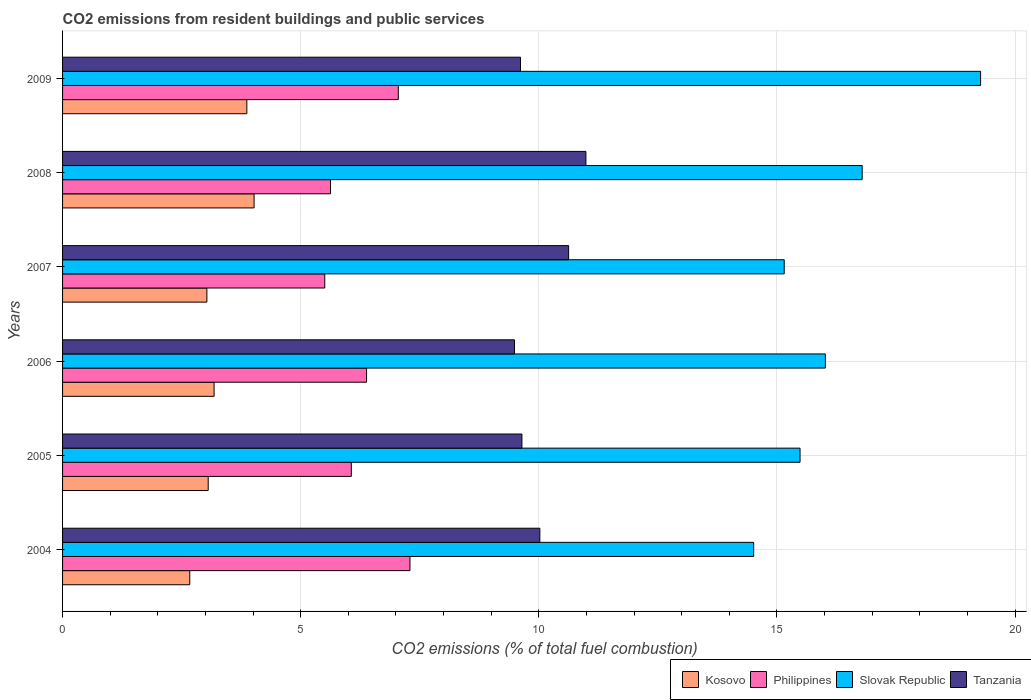Are the number of bars per tick equal to the number of legend labels?
Provide a succinct answer. Yes. Are the number of bars on each tick of the Y-axis equal?
Provide a succinct answer. Yes. How many bars are there on the 2nd tick from the top?
Give a very brief answer. 4. What is the total CO2 emitted in Philippines in 2008?
Provide a short and direct response. 5.63. Across all years, what is the maximum total CO2 emitted in Slovak Republic?
Provide a succinct answer. 19.28. Across all years, what is the minimum total CO2 emitted in Slovak Republic?
Provide a short and direct response. 14.51. In which year was the total CO2 emitted in Tanzania maximum?
Give a very brief answer. 2008. In which year was the total CO2 emitted in Slovak Republic minimum?
Your response must be concise. 2004. What is the total total CO2 emitted in Slovak Republic in the graph?
Your response must be concise. 97.23. What is the difference between the total CO2 emitted in Tanzania in 2004 and that in 2008?
Keep it short and to the point. -0.97. What is the difference between the total CO2 emitted in Tanzania in 2006 and the total CO2 emitted in Philippines in 2008?
Your answer should be very brief. 3.86. What is the average total CO2 emitted in Philippines per year?
Provide a succinct answer. 6.32. In the year 2007, what is the difference between the total CO2 emitted in Tanzania and total CO2 emitted in Philippines?
Your answer should be very brief. 5.12. In how many years, is the total CO2 emitted in Philippines greater than 10 ?
Keep it short and to the point. 0. What is the ratio of the total CO2 emitted in Philippines in 2005 to that in 2009?
Your answer should be very brief. 0.86. Is the total CO2 emitted in Philippines in 2007 less than that in 2009?
Provide a succinct answer. Yes. What is the difference between the highest and the second highest total CO2 emitted in Tanzania?
Make the answer very short. 0.36. What is the difference between the highest and the lowest total CO2 emitted in Kosovo?
Your answer should be very brief. 1.35. Is the sum of the total CO2 emitted in Slovak Republic in 2004 and 2006 greater than the maximum total CO2 emitted in Philippines across all years?
Ensure brevity in your answer.  Yes. What does the 4th bar from the top in 2009 represents?
Offer a very short reply. Kosovo. What does the 3rd bar from the bottom in 2004 represents?
Ensure brevity in your answer.  Slovak Republic. Are all the bars in the graph horizontal?
Give a very brief answer. Yes. Are the values on the major ticks of X-axis written in scientific E-notation?
Provide a short and direct response. No. Does the graph contain grids?
Provide a succinct answer. Yes. What is the title of the graph?
Provide a short and direct response. CO2 emissions from resident buildings and public services. What is the label or title of the X-axis?
Keep it short and to the point. CO2 emissions (% of total fuel combustion). What is the CO2 emissions (% of total fuel combustion) in Kosovo in 2004?
Make the answer very short. 2.67. What is the CO2 emissions (% of total fuel combustion) of Philippines in 2004?
Provide a succinct answer. 7.29. What is the CO2 emissions (% of total fuel combustion) in Slovak Republic in 2004?
Your answer should be very brief. 14.51. What is the CO2 emissions (% of total fuel combustion) in Tanzania in 2004?
Offer a terse response. 10.02. What is the CO2 emissions (% of total fuel combustion) of Kosovo in 2005?
Keep it short and to the point. 3.06. What is the CO2 emissions (% of total fuel combustion) in Philippines in 2005?
Your response must be concise. 6.06. What is the CO2 emissions (% of total fuel combustion) of Slovak Republic in 2005?
Your response must be concise. 15.49. What is the CO2 emissions (% of total fuel combustion) of Tanzania in 2005?
Provide a short and direct response. 9.65. What is the CO2 emissions (% of total fuel combustion) in Kosovo in 2006?
Your answer should be compact. 3.18. What is the CO2 emissions (% of total fuel combustion) in Philippines in 2006?
Make the answer very short. 6.38. What is the CO2 emissions (% of total fuel combustion) of Slovak Republic in 2006?
Make the answer very short. 16.02. What is the CO2 emissions (% of total fuel combustion) in Tanzania in 2006?
Give a very brief answer. 9.49. What is the CO2 emissions (% of total fuel combustion) in Kosovo in 2007?
Your answer should be very brief. 3.03. What is the CO2 emissions (% of total fuel combustion) of Philippines in 2007?
Offer a very short reply. 5.51. What is the CO2 emissions (% of total fuel combustion) in Slovak Republic in 2007?
Make the answer very short. 15.15. What is the CO2 emissions (% of total fuel combustion) in Tanzania in 2007?
Your answer should be very brief. 10.63. What is the CO2 emissions (% of total fuel combustion) of Kosovo in 2008?
Offer a very short reply. 4.02. What is the CO2 emissions (% of total fuel combustion) in Philippines in 2008?
Give a very brief answer. 5.63. What is the CO2 emissions (% of total fuel combustion) of Slovak Republic in 2008?
Your answer should be very brief. 16.79. What is the CO2 emissions (% of total fuel combustion) of Tanzania in 2008?
Your answer should be very brief. 10.99. What is the CO2 emissions (% of total fuel combustion) in Kosovo in 2009?
Offer a terse response. 3.87. What is the CO2 emissions (% of total fuel combustion) in Philippines in 2009?
Offer a terse response. 7.05. What is the CO2 emissions (% of total fuel combustion) in Slovak Republic in 2009?
Your response must be concise. 19.28. What is the CO2 emissions (% of total fuel combustion) in Tanzania in 2009?
Your answer should be compact. 9.62. Across all years, what is the maximum CO2 emissions (% of total fuel combustion) in Kosovo?
Your answer should be compact. 4.02. Across all years, what is the maximum CO2 emissions (% of total fuel combustion) in Philippines?
Your answer should be very brief. 7.29. Across all years, what is the maximum CO2 emissions (% of total fuel combustion) of Slovak Republic?
Your answer should be very brief. 19.28. Across all years, what is the maximum CO2 emissions (% of total fuel combustion) in Tanzania?
Your answer should be very brief. 10.99. Across all years, what is the minimum CO2 emissions (% of total fuel combustion) of Kosovo?
Your answer should be compact. 2.67. Across all years, what is the minimum CO2 emissions (% of total fuel combustion) in Philippines?
Provide a succinct answer. 5.51. Across all years, what is the minimum CO2 emissions (% of total fuel combustion) of Slovak Republic?
Offer a very short reply. 14.51. Across all years, what is the minimum CO2 emissions (% of total fuel combustion) in Tanzania?
Ensure brevity in your answer.  9.49. What is the total CO2 emissions (% of total fuel combustion) in Kosovo in the graph?
Make the answer very short. 19.83. What is the total CO2 emissions (% of total fuel combustion) in Philippines in the graph?
Your answer should be very brief. 37.92. What is the total CO2 emissions (% of total fuel combustion) in Slovak Republic in the graph?
Provide a succinct answer. 97.23. What is the total CO2 emissions (% of total fuel combustion) of Tanzania in the graph?
Give a very brief answer. 60.39. What is the difference between the CO2 emissions (% of total fuel combustion) in Kosovo in 2004 and that in 2005?
Give a very brief answer. -0.39. What is the difference between the CO2 emissions (% of total fuel combustion) of Philippines in 2004 and that in 2005?
Your answer should be very brief. 1.23. What is the difference between the CO2 emissions (% of total fuel combustion) of Slovak Republic in 2004 and that in 2005?
Offer a very short reply. -0.97. What is the difference between the CO2 emissions (% of total fuel combustion) in Tanzania in 2004 and that in 2005?
Provide a succinct answer. 0.38. What is the difference between the CO2 emissions (% of total fuel combustion) in Kosovo in 2004 and that in 2006?
Give a very brief answer. -0.51. What is the difference between the CO2 emissions (% of total fuel combustion) in Philippines in 2004 and that in 2006?
Ensure brevity in your answer.  0.91. What is the difference between the CO2 emissions (% of total fuel combustion) of Slovak Republic in 2004 and that in 2006?
Ensure brevity in your answer.  -1.51. What is the difference between the CO2 emissions (% of total fuel combustion) in Tanzania in 2004 and that in 2006?
Provide a short and direct response. 0.53. What is the difference between the CO2 emissions (% of total fuel combustion) of Kosovo in 2004 and that in 2007?
Your response must be concise. -0.36. What is the difference between the CO2 emissions (% of total fuel combustion) in Philippines in 2004 and that in 2007?
Offer a very short reply. 1.79. What is the difference between the CO2 emissions (% of total fuel combustion) of Slovak Republic in 2004 and that in 2007?
Keep it short and to the point. -0.64. What is the difference between the CO2 emissions (% of total fuel combustion) in Tanzania in 2004 and that in 2007?
Offer a terse response. -0.6. What is the difference between the CO2 emissions (% of total fuel combustion) in Kosovo in 2004 and that in 2008?
Keep it short and to the point. -1.35. What is the difference between the CO2 emissions (% of total fuel combustion) of Philippines in 2004 and that in 2008?
Provide a succinct answer. 1.67. What is the difference between the CO2 emissions (% of total fuel combustion) in Slovak Republic in 2004 and that in 2008?
Provide a succinct answer. -2.28. What is the difference between the CO2 emissions (% of total fuel combustion) of Tanzania in 2004 and that in 2008?
Ensure brevity in your answer.  -0.97. What is the difference between the CO2 emissions (% of total fuel combustion) in Kosovo in 2004 and that in 2009?
Provide a succinct answer. -1.2. What is the difference between the CO2 emissions (% of total fuel combustion) of Philippines in 2004 and that in 2009?
Offer a terse response. 0.24. What is the difference between the CO2 emissions (% of total fuel combustion) in Slovak Republic in 2004 and that in 2009?
Provide a short and direct response. -4.76. What is the difference between the CO2 emissions (% of total fuel combustion) in Tanzania in 2004 and that in 2009?
Ensure brevity in your answer.  0.41. What is the difference between the CO2 emissions (% of total fuel combustion) of Kosovo in 2005 and that in 2006?
Keep it short and to the point. -0.12. What is the difference between the CO2 emissions (% of total fuel combustion) in Philippines in 2005 and that in 2006?
Offer a terse response. -0.32. What is the difference between the CO2 emissions (% of total fuel combustion) of Slovak Republic in 2005 and that in 2006?
Your response must be concise. -0.53. What is the difference between the CO2 emissions (% of total fuel combustion) in Tanzania in 2005 and that in 2006?
Provide a succinct answer. 0.16. What is the difference between the CO2 emissions (% of total fuel combustion) of Kosovo in 2005 and that in 2007?
Your response must be concise. 0.03. What is the difference between the CO2 emissions (% of total fuel combustion) in Philippines in 2005 and that in 2007?
Your response must be concise. 0.56. What is the difference between the CO2 emissions (% of total fuel combustion) of Slovak Republic in 2005 and that in 2007?
Provide a short and direct response. 0.33. What is the difference between the CO2 emissions (% of total fuel combustion) in Tanzania in 2005 and that in 2007?
Provide a succinct answer. -0.98. What is the difference between the CO2 emissions (% of total fuel combustion) in Kosovo in 2005 and that in 2008?
Provide a short and direct response. -0.96. What is the difference between the CO2 emissions (% of total fuel combustion) in Philippines in 2005 and that in 2008?
Offer a very short reply. 0.44. What is the difference between the CO2 emissions (% of total fuel combustion) of Slovak Republic in 2005 and that in 2008?
Provide a short and direct response. -1.3. What is the difference between the CO2 emissions (% of total fuel combustion) in Tanzania in 2005 and that in 2008?
Provide a short and direct response. -1.34. What is the difference between the CO2 emissions (% of total fuel combustion) of Kosovo in 2005 and that in 2009?
Keep it short and to the point. -0.81. What is the difference between the CO2 emissions (% of total fuel combustion) in Philippines in 2005 and that in 2009?
Your response must be concise. -0.99. What is the difference between the CO2 emissions (% of total fuel combustion) in Slovak Republic in 2005 and that in 2009?
Ensure brevity in your answer.  -3.79. What is the difference between the CO2 emissions (% of total fuel combustion) of Tanzania in 2005 and that in 2009?
Ensure brevity in your answer.  0.03. What is the difference between the CO2 emissions (% of total fuel combustion) in Kosovo in 2006 and that in 2007?
Offer a very short reply. 0.15. What is the difference between the CO2 emissions (% of total fuel combustion) of Philippines in 2006 and that in 2007?
Ensure brevity in your answer.  0.88. What is the difference between the CO2 emissions (% of total fuel combustion) of Slovak Republic in 2006 and that in 2007?
Offer a terse response. 0.86. What is the difference between the CO2 emissions (% of total fuel combustion) of Tanzania in 2006 and that in 2007?
Offer a very short reply. -1.14. What is the difference between the CO2 emissions (% of total fuel combustion) in Kosovo in 2006 and that in 2008?
Your response must be concise. -0.84. What is the difference between the CO2 emissions (% of total fuel combustion) in Philippines in 2006 and that in 2008?
Your response must be concise. 0.76. What is the difference between the CO2 emissions (% of total fuel combustion) in Slovak Republic in 2006 and that in 2008?
Provide a short and direct response. -0.77. What is the difference between the CO2 emissions (% of total fuel combustion) of Kosovo in 2006 and that in 2009?
Give a very brief answer. -0.69. What is the difference between the CO2 emissions (% of total fuel combustion) in Philippines in 2006 and that in 2009?
Your response must be concise. -0.67. What is the difference between the CO2 emissions (% of total fuel combustion) of Slovak Republic in 2006 and that in 2009?
Provide a short and direct response. -3.26. What is the difference between the CO2 emissions (% of total fuel combustion) in Tanzania in 2006 and that in 2009?
Provide a short and direct response. -0.13. What is the difference between the CO2 emissions (% of total fuel combustion) of Kosovo in 2007 and that in 2008?
Make the answer very short. -0.99. What is the difference between the CO2 emissions (% of total fuel combustion) of Philippines in 2007 and that in 2008?
Offer a terse response. -0.12. What is the difference between the CO2 emissions (% of total fuel combustion) in Slovak Republic in 2007 and that in 2008?
Keep it short and to the point. -1.64. What is the difference between the CO2 emissions (% of total fuel combustion) of Tanzania in 2007 and that in 2008?
Offer a very short reply. -0.36. What is the difference between the CO2 emissions (% of total fuel combustion) in Kosovo in 2007 and that in 2009?
Provide a succinct answer. -0.84. What is the difference between the CO2 emissions (% of total fuel combustion) of Philippines in 2007 and that in 2009?
Provide a short and direct response. -1.54. What is the difference between the CO2 emissions (% of total fuel combustion) in Slovak Republic in 2007 and that in 2009?
Your response must be concise. -4.12. What is the difference between the CO2 emissions (% of total fuel combustion) in Tanzania in 2007 and that in 2009?
Give a very brief answer. 1.01. What is the difference between the CO2 emissions (% of total fuel combustion) of Kosovo in 2008 and that in 2009?
Provide a short and direct response. 0.15. What is the difference between the CO2 emissions (% of total fuel combustion) in Philippines in 2008 and that in 2009?
Make the answer very short. -1.42. What is the difference between the CO2 emissions (% of total fuel combustion) in Slovak Republic in 2008 and that in 2009?
Your answer should be very brief. -2.49. What is the difference between the CO2 emissions (% of total fuel combustion) of Tanzania in 2008 and that in 2009?
Provide a succinct answer. 1.37. What is the difference between the CO2 emissions (% of total fuel combustion) in Kosovo in 2004 and the CO2 emissions (% of total fuel combustion) in Philippines in 2005?
Ensure brevity in your answer.  -3.39. What is the difference between the CO2 emissions (% of total fuel combustion) of Kosovo in 2004 and the CO2 emissions (% of total fuel combustion) of Slovak Republic in 2005?
Give a very brief answer. -12.81. What is the difference between the CO2 emissions (% of total fuel combustion) of Kosovo in 2004 and the CO2 emissions (% of total fuel combustion) of Tanzania in 2005?
Keep it short and to the point. -6.97. What is the difference between the CO2 emissions (% of total fuel combustion) in Philippines in 2004 and the CO2 emissions (% of total fuel combustion) in Slovak Republic in 2005?
Offer a very short reply. -8.19. What is the difference between the CO2 emissions (% of total fuel combustion) of Philippines in 2004 and the CO2 emissions (% of total fuel combustion) of Tanzania in 2005?
Give a very brief answer. -2.35. What is the difference between the CO2 emissions (% of total fuel combustion) in Slovak Republic in 2004 and the CO2 emissions (% of total fuel combustion) in Tanzania in 2005?
Keep it short and to the point. 4.87. What is the difference between the CO2 emissions (% of total fuel combustion) in Kosovo in 2004 and the CO2 emissions (% of total fuel combustion) in Philippines in 2006?
Keep it short and to the point. -3.71. What is the difference between the CO2 emissions (% of total fuel combustion) in Kosovo in 2004 and the CO2 emissions (% of total fuel combustion) in Slovak Republic in 2006?
Give a very brief answer. -13.35. What is the difference between the CO2 emissions (% of total fuel combustion) in Kosovo in 2004 and the CO2 emissions (% of total fuel combustion) in Tanzania in 2006?
Offer a very short reply. -6.82. What is the difference between the CO2 emissions (% of total fuel combustion) in Philippines in 2004 and the CO2 emissions (% of total fuel combustion) in Slovak Republic in 2006?
Your answer should be very brief. -8.72. What is the difference between the CO2 emissions (% of total fuel combustion) in Philippines in 2004 and the CO2 emissions (% of total fuel combustion) in Tanzania in 2006?
Keep it short and to the point. -2.19. What is the difference between the CO2 emissions (% of total fuel combustion) of Slovak Republic in 2004 and the CO2 emissions (% of total fuel combustion) of Tanzania in 2006?
Give a very brief answer. 5.02. What is the difference between the CO2 emissions (% of total fuel combustion) in Kosovo in 2004 and the CO2 emissions (% of total fuel combustion) in Philippines in 2007?
Keep it short and to the point. -2.84. What is the difference between the CO2 emissions (% of total fuel combustion) of Kosovo in 2004 and the CO2 emissions (% of total fuel combustion) of Slovak Republic in 2007?
Provide a succinct answer. -12.48. What is the difference between the CO2 emissions (% of total fuel combustion) of Kosovo in 2004 and the CO2 emissions (% of total fuel combustion) of Tanzania in 2007?
Ensure brevity in your answer.  -7.96. What is the difference between the CO2 emissions (% of total fuel combustion) of Philippines in 2004 and the CO2 emissions (% of total fuel combustion) of Slovak Republic in 2007?
Give a very brief answer. -7.86. What is the difference between the CO2 emissions (% of total fuel combustion) in Philippines in 2004 and the CO2 emissions (% of total fuel combustion) in Tanzania in 2007?
Provide a succinct answer. -3.33. What is the difference between the CO2 emissions (% of total fuel combustion) of Slovak Republic in 2004 and the CO2 emissions (% of total fuel combustion) of Tanzania in 2007?
Offer a terse response. 3.89. What is the difference between the CO2 emissions (% of total fuel combustion) of Kosovo in 2004 and the CO2 emissions (% of total fuel combustion) of Philippines in 2008?
Offer a very short reply. -2.96. What is the difference between the CO2 emissions (% of total fuel combustion) in Kosovo in 2004 and the CO2 emissions (% of total fuel combustion) in Slovak Republic in 2008?
Give a very brief answer. -14.12. What is the difference between the CO2 emissions (% of total fuel combustion) in Kosovo in 2004 and the CO2 emissions (% of total fuel combustion) in Tanzania in 2008?
Give a very brief answer. -8.32. What is the difference between the CO2 emissions (% of total fuel combustion) of Philippines in 2004 and the CO2 emissions (% of total fuel combustion) of Slovak Republic in 2008?
Provide a short and direct response. -9.5. What is the difference between the CO2 emissions (% of total fuel combustion) of Philippines in 2004 and the CO2 emissions (% of total fuel combustion) of Tanzania in 2008?
Provide a succinct answer. -3.69. What is the difference between the CO2 emissions (% of total fuel combustion) in Slovak Republic in 2004 and the CO2 emissions (% of total fuel combustion) in Tanzania in 2008?
Give a very brief answer. 3.52. What is the difference between the CO2 emissions (% of total fuel combustion) in Kosovo in 2004 and the CO2 emissions (% of total fuel combustion) in Philippines in 2009?
Give a very brief answer. -4.38. What is the difference between the CO2 emissions (% of total fuel combustion) in Kosovo in 2004 and the CO2 emissions (% of total fuel combustion) in Slovak Republic in 2009?
Give a very brief answer. -16.61. What is the difference between the CO2 emissions (% of total fuel combustion) of Kosovo in 2004 and the CO2 emissions (% of total fuel combustion) of Tanzania in 2009?
Offer a terse response. -6.94. What is the difference between the CO2 emissions (% of total fuel combustion) of Philippines in 2004 and the CO2 emissions (% of total fuel combustion) of Slovak Republic in 2009?
Ensure brevity in your answer.  -11.98. What is the difference between the CO2 emissions (% of total fuel combustion) of Philippines in 2004 and the CO2 emissions (% of total fuel combustion) of Tanzania in 2009?
Your response must be concise. -2.32. What is the difference between the CO2 emissions (% of total fuel combustion) of Slovak Republic in 2004 and the CO2 emissions (% of total fuel combustion) of Tanzania in 2009?
Offer a terse response. 4.9. What is the difference between the CO2 emissions (% of total fuel combustion) in Kosovo in 2005 and the CO2 emissions (% of total fuel combustion) in Philippines in 2006?
Provide a short and direct response. -3.33. What is the difference between the CO2 emissions (% of total fuel combustion) in Kosovo in 2005 and the CO2 emissions (% of total fuel combustion) in Slovak Republic in 2006?
Your answer should be compact. -12.96. What is the difference between the CO2 emissions (% of total fuel combustion) in Kosovo in 2005 and the CO2 emissions (% of total fuel combustion) in Tanzania in 2006?
Ensure brevity in your answer.  -6.43. What is the difference between the CO2 emissions (% of total fuel combustion) in Philippines in 2005 and the CO2 emissions (% of total fuel combustion) in Slovak Republic in 2006?
Provide a short and direct response. -9.95. What is the difference between the CO2 emissions (% of total fuel combustion) of Philippines in 2005 and the CO2 emissions (% of total fuel combustion) of Tanzania in 2006?
Make the answer very short. -3.43. What is the difference between the CO2 emissions (% of total fuel combustion) in Slovak Republic in 2005 and the CO2 emissions (% of total fuel combustion) in Tanzania in 2006?
Offer a terse response. 6. What is the difference between the CO2 emissions (% of total fuel combustion) of Kosovo in 2005 and the CO2 emissions (% of total fuel combustion) of Philippines in 2007?
Give a very brief answer. -2.45. What is the difference between the CO2 emissions (% of total fuel combustion) of Kosovo in 2005 and the CO2 emissions (% of total fuel combustion) of Slovak Republic in 2007?
Keep it short and to the point. -12.1. What is the difference between the CO2 emissions (% of total fuel combustion) in Kosovo in 2005 and the CO2 emissions (% of total fuel combustion) in Tanzania in 2007?
Make the answer very short. -7.57. What is the difference between the CO2 emissions (% of total fuel combustion) of Philippines in 2005 and the CO2 emissions (% of total fuel combustion) of Slovak Republic in 2007?
Your answer should be compact. -9.09. What is the difference between the CO2 emissions (% of total fuel combustion) of Philippines in 2005 and the CO2 emissions (% of total fuel combustion) of Tanzania in 2007?
Give a very brief answer. -4.56. What is the difference between the CO2 emissions (% of total fuel combustion) in Slovak Republic in 2005 and the CO2 emissions (% of total fuel combustion) in Tanzania in 2007?
Give a very brief answer. 4.86. What is the difference between the CO2 emissions (% of total fuel combustion) in Kosovo in 2005 and the CO2 emissions (% of total fuel combustion) in Philippines in 2008?
Provide a succinct answer. -2.57. What is the difference between the CO2 emissions (% of total fuel combustion) in Kosovo in 2005 and the CO2 emissions (% of total fuel combustion) in Slovak Republic in 2008?
Your answer should be compact. -13.73. What is the difference between the CO2 emissions (% of total fuel combustion) of Kosovo in 2005 and the CO2 emissions (% of total fuel combustion) of Tanzania in 2008?
Make the answer very short. -7.93. What is the difference between the CO2 emissions (% of total fuel combustion) of Philippines in 2005 and the CO2 emissions (% of total fuel combustion) of Slovak Republic in 2008?
Make the answer very short. -10.73. What is the difference between the CO2 emissions (% of total fuel combustion) in Philippines in 2005 and the CO2 emissions (% of total fuel combustion) in Tanzania in 2008?
Keep it short and to the point. -4.93. What is the difference between the CO2 emissions (% of total fuel combustion) of Slovak Republic in 2005 and the CO2 emissions (% of total fuel combustion) of Tanzania in 2008?
Ensure brevity in your answer.  4.5. What is the difference between the CO2 emissions (% of total fuel combustion) of Kosovo in 2005 and the CO2 emissions (% of total fuel combustion) of Philippines in 2009?
Provide a short and direct response. -3.99. What is the difference between the CO2 emissions (% of total fuel combustion) of Kosovo in 2005 and the CO2 emissions (% of total fuel combustion) of Slovak Republic in 2009?
Your answer should be very brief. -16.22. What is the difference between the CO2 emissions (% of total fuel combustion) in Kosovo in 2005 and the CO2 emissions (% of total fuel combustion) in Tanzania in 2009?
Offer a very short reply. -6.56. What is the difference between the CO2 emissions (% of total fuel combustion) in Philippines in 2005 and the CO2 emissions (% of total fuel combustion) in Slovak Republic in 2009?
Keep it short and to the point. -13.21. What is the difference between the CO2 emissions (% of total fuel combustion) in Philippines in 2005 and the CO2 emissions (% of total fuel combustion) in Tanzania in 2009?
Your response must be concise. -3.55. What is the difference between the CO2 emissions (% of total fuel combustion) in Slovak Republic in 2005 and the CO2 emissions (% of total fuel combustion) in Tanzania in 2009?
Provide a short and direct response. 5.87. What is the difference between the CO2 emissions (% of total fuel combustion) of Kosovo in 2006 and the CO2 emissions (% of total fuel combustion) of Philippines in 2007?
Ensure brevity in your answer.  -2.32. What is the difference between the CO2 emissions (% of total fuel combustion) of Kosovo in 2006 and the CO2 emissions (% of total fuel combustion) of Slovak Republic in 2007?
Keep it short and to the point. -11.97. What is the difference between the CO2 emissions (% of total fuel combustion) of Kosovo in 2006 and the CO2 emissions (% of total fuel combustion) of Tanzania in 2007?
Offer a terse response. -7.44. What is the difference between the CO2 emissions (% of total fuel combustion) of Philippines in 2006 and the CO2 emissions (% of total fuel combustion) of Slovak Republic in 2007?
Your answer should be very brief. -8.77. What is the difference between the CO2 emissions (% of total fuel combustion) of Philippines in 2006 and the CO2 emissions (% of total fuel combustion) of Tanzania in 2007?
Keep it short and to the point. -4.24. What is the difference between the CO2 emissions (% of total fuel combustion) in Slovak Republic in 2006 and the CO2 emissions (% of total fuel combustion) in Tanzania in 2007?
Your answer should be very brief. 5.39. What is the difference between the CO2 emissions (% of total fuel combustion) of Kosovo in 2006 and the CO2 emissions (% of total fuel combustion) of Philippines in 2008?
Provide a short and direct response. -2.44. What is the difference between the CO2 emissions (% of total fuel combustion) in Kosovo in 2006 and the CO2 emissions (% of total fuel combustion) in Slovak Republic in 2008?
Your answer should be very brief. -13.61. What is the difference between the CO2 emissions (% of total fuel combustion) of Kosovo in 2006 and the CO2 emissions (% of total fuel combustion) of Tanzania in 2008?
Your answer should be very brief. -7.81. What is the difference between the CO2 emissions (% of total fuel combustion) of Philippines in 2006 and the CO2 emissions (% of total fuel combustion) of Slovak Republic in 2008?
Provide a succinct answer. -10.41. What is the difference between the CO2 emissions (% of total fuel combustion) of Philippines in 2006 and the CO2 emissions (% of total fuel combustion) of Tanzania in 2008?
Your answer should be very brief. -4.61. What is the difference between the CO2 emissions (% of total fuel combustion) of Slovak Republic in 2006 and the CO2 emissions (% of total fuel combustion) of Tanzania in 2008?
Your answer should be very brief. 5.03. What is the difference between the CO2 emissions (% of total fuel combustion) of Kosovo in 2006 and the CO2 emissions (% of total fuel combustion) of Philippines in 2009?
Keep it short and to the point. -3.87. What is the difference between the CO2 emissions (% of total fuel combustion) in Kosovo in 2006 and the CO2 emissions (% of total fuel combustion) in Slovak Republic in 2009?
Offer a terse response. -16.09. What is the difference between the CO2 emissions (% of total fuel combustion) of Kosovo in 2006 and the CO2 emissions (% of total fuel combustion) of Tanzania in 2009?
Make the answer very short. -6.43. What is the difference between the CO2 emissions (% of total fuel combustion) in Philippines in 2006 and the CO2 emissions (% of total fuel combustion) in Slovak Republic in 2009?
Ensure brevity in your answer.  -12.89. What is the difference between the CO2 emissions (% of total fuel combustion) in Philippines in 2006 and the CO2 emissions (% of total fuel combustion) in Tanzania in 2009?
Provide a succinct answer. -3.23. What is the difference between the CO2 emissions (% of total fuel combustion) in Slovak Republic in 2006 and the CO2 emissions (% of total fuel combustion) in Tanzania in 2009?
Your response must be concise. 6.4. What is the difference between the CO2 emissions (% of total fuel combustion) in Kosovo in 2007 and the CO2 emissions (% of total fuel combustion) in Philippines in 2008?
Provide a succinct answer. -2.6. What is the difference between the CO2 emissions (% of total fuel combustion) in Kosovo in 2007 and the CO2 emissions (% of total fuel combustion) in Slovak Republic in 2008?
Make the answer very short. -13.76. What is the difference between the CO2 emissions (% of total fuel combustion) in Kosovo in 2007 and the CO2 emissions (% of total fuel combustion) in Tanzania in 2008?
Your answer should be very brief. -7.96. What is the difference between the CO2 emissions (% of total fuel combustion) of Philippines in 2007 and the CO2 emissions (% of total fuel combustion) of Slovak Republic in 2008?
Make the answer very short. -11.28. What is the difference between the CO2 emissions (% of total fuel combustion) in Philippines in 2007 and the CO2 emissions (% of total fuel combustion) in Tanzania in 2008?
Keep it short and to the point. -5.48. What is the difference between the CO2 emissions (% of total fuel combustion) in Slovak Republic in 2007 and the CO2 emissions (% of total fuel combustion) in Tanzania in 2008?
Your answer should be very brief. 4.16. What is the difference between the CO2 emissions (% of total fuel combustion) of Kosovo in 2007 and the CO2 emissions (% of total fuel combustion) of Philippines in 2009?
Give a very brief answer. -4.02. What is the difference between the CO2 emissions (% of total fuel combustion) of Kosovo in 2007 and the CO2 emissions (% of total fuel combustion) of Slovak Republic in 2009?
Provide a short and direct response. -16.25. What is the difference between the CO2 emissions (% of total fuel combustion) in Kosovo in 2007 and the CO2 emissions (% of total fuel combustion) in Tanzania in 2009?
Offer a very short reply. -6.59. What is the difference between the CO2 emissions (% of total fuel combustion) in Philippines in 2007 and the CO2 emissions (% of total fuel combustion) in Slovak Republic in 2009?
Keep it short and to the point. -13.77. What is the difference between the CO2 emissions (% of total fuel combustion) in Philippines in 2007 and the CO2 emissions (% of total fuel combustion) in Tanzania in 2009?
Your answer should be compact. -4.11. What is the difference between the CO2 emissions (% of total fuel combustion) of Slovak Republic in 2007 and the CO2 emissions (% of total fuel combustion) of Tanzania in 2009?
Provide a short and direct response. 5.54. What is the difference between the CO2 emissions (% of total fuel combustion) of Kosovo in 2008 and the CO2 emissions (% of total fuel combustion) of Philippines in 2009?
Offer a very short reply. -3.03. What is the difference between the CO2 emissions (% of total fuel combustion) in Kosovo in 2008 and the CO2 emissions (% of total fuel combustion) in Slovak Republic in 2009?
Provide a short and direct response. -15.26. What is the difference between the CO2 emissions (% of total fuel combustion) in Kosovo in 2008 and the CO2 emissions (% of total fuel combustion) in Tanzania in 2009?
Provide a short and direct response. -5.59. What is the difference between the CO2 emissions (% of total fuel combustion) in Philippines in 2008 and the CO2 emissions (% of total fuel combustion) in Slovak Republic in 2009?
Offer a terse response. -13.65. What is the difference between the CO2 emissions (% of total fuel combustion) of Philippines in 2008 and the CO2 emissions (% of total fuel combustion) of Tanzania in 2009?
Make the answer very short. -3.99. What is the difference between the CO2 emissions (% of total fuel combustion) of Slovak Republic in 2008 and the CO2 emissions (% of total fuel combustion) of Tanzania in 2009?
Provide a succinct answer. 7.17. What is the average CO2 emissions (% of total fuel combustion) in Kosovo per year?
Provide a succinct answer. 3.31. What is the average CO2 emissions (% of total fuel combustion) in Philippines per year?
Make the answer very short. 6.32. What is the average CO2 emissions (% of total fuel combustion) of Slovak Republic per year?
Make the answer very short. 16.21. What is the average CO2 emissions (% of total fuel combustion) of Tanzania per year?
Your answer should be compact. 10.06. In the year 2004, what is the difference between the CO2 emissions (% of total fuel combustion) of Kosovo and CO2 emissions (% of total fuel combustion) of Philippines?
Keep it short and to the point. -4.62. In the year 2004, what is the difference between the CO2 emissions (% of total fuel combustion) of Kosovo and CO2 emissions (% of total fuel combustion) of Slovak Republic?
Offer a very short reply. -11.84. In the year 2004, what is the difference between the CO2 emissions (% of total fuel combustion) in Kosovo and CO2 emissions (% of total fuel combustion) in Tanzania?
Your answer should be compact. -7.35. In the year 2004, what is the difference between the CO2 emissions (% of total fuel combustion) of Philippines and CO2 emissions (% of total fuel combustion) of Slovak Republic?
Keep it short and to the point. -7.22. In the year 2004, what is the difference between the CO2 emissions (% of total fuel combustion) in Philippines and CO2 emissions (% of total fuel combustion) in Tanzania?
Give a very brief answer. -2.73. In the year 2004, what is the difference between the CO2 emissions (% of total fuel combustion) of Slovak Republic and CO2 emissions (% of total fuel combustion) of Tanzania?
Keep it short and to the point. 4.49. In the year 2005, what is the difference between the CO2 emissions (% of total fuel combustion) of Kosovo and CO2 emissions (% of total fuel combustion) of Philippines?
Your answer should be very brief. -3.01. In the year 2005, what is the difference between the CO2 emissions (% of total fuel combustion) of Kosovo and CO2 emissions (% of total fuel combustion) of Slovak Republic?
Give a very brief answer. -12.43. In the year 2005, what is the difference between the CO2 emissions (% of total fuel combustion) of Kosovo and CO2 emissions (% of total fuel combustion) of Tanzania?
Keep it short and to the point. -6.59. In the year 2005, what is the difference between the CO2 emissions (% of total fuel combustion) of Philippines and CO2 emissions (% of total fuel combustion) of Slovak Republic?
Give a very brief answer. -9.42. In the year 2005, what is the difference between the CO2 emissions (% of total fuel combustion) of Philippines and CO2 emissions (% of total fuel combustion) of Tanzania?
Give a very brief answer. -3.58. In the year 2005, what is the difference between the CO2 emissions (% of total fuel combustion) in Slovak Republic and CO2 emissions (% of total fuel combustion) in Tanzania?
Your answer should be compact. 5.84. In the year 2006, what is the difference between the CO2 emissions (% of total fuel combustion) in Kosovo and CO2 emissions (% of total fuel combustion) in Philippines?
Offer a very short reply. -3.2. In the year 2006, what is the difference between the CO2 emissions (% of total fuel combustion) of Kosovo and CO2 emissions (% of total fuel combustion) of Slovak Republic?
Keep it short and to the point. -12.84. In the year 2006, what is the difference between the CO2 emissions (% of total fuel combustion) of Kosovo and CO2 emissions (% of total fuel combustion) of Tanzania?
Keep it short and to the point. -6.31. In the year 2006, what is the difference between the CO2 emissions (% of total fuel combustion) of Philippines and CO2 emissions (% of total fuel combustion) of Slovak Republic?
Make the answer very short. -9.63. In the year 2006, what is the difference between the CO2 emissions (% of total fuel combustion) in Philippines and CO2 emissions (% of total fuel combustion) in Tanzania?
Provide a short and direct response. -3.11. In the year 2006, what is the difference between the CO2 emissions (% of total fuel combustion) of Slovak Republic and CO2 emissions (% of total fuel combustion) of Tanzania?
Ensure brevity in your answer.  6.53. In the year 2007, what is the difference between the CO2 emissions (% of total fuel combustion) of Kosovo and CO2 emissions (% of total fuel combustion) of Philippines?
Keep it short and to the point. -2.48. In the year 2007, what is the difference between the CO2 emissions (% of total fuel combustion) of Kosovo and CO2 emissions (% of total fuel combustion) of Slovak Republic?
Make the answer very short. -12.12. In the year 2007, what is the difference between the CO2 emissions (% of total fuel combustion) in Kosovo and CO2 emissions (% of total fuel combustion) in Tanzania?
Offer a very short reply. -7.6. In the year 2007, what is the difference between the CO2 emissions (% of total fuel combustion) of Philippines and CO2 emissions (% of total fuel combustion) of Slovak Republic?
Ensure brevity in your answer.  -9.65. In the year 2007, what is the difference between the CO2 emissions (% of total fuel combustion) of Philippines and CO2 emissions (% of total fuel combustion) of Tanzania?
Ensure brevity in your answer.  -5.12. In the year 2007, what is the difference between the CO2 emissions (% of total fuel combustion) in Slovak Republic and CO2 emissions (% of total fuel combustion) in Tanzania?
Offer a very short reply. 4.53. In the year 2008, what is the difference between the CO2 emissions (% of total fuel combustion) in Kosovo and CO2 emissions (% of total fuel combustion) in Philippines?
Keep it short and to the point. -1.61. In the year 2008, what is the difference between the CO2 emissions (% of total fuel combustion) in Kosovo and CO2 emissions (% of total fuel combustion) in Slovak Republic?
Ensure brevity in your answer.  -12.77. In the year 2008, what is the difference between the CO2 emissions (% of total fuel combustion) in Kosovo and CO2 emissions (% of total fuel combustion) in Tanzania?
Ensure brevity in your answer.  -6.97. In the year 2008, what is the difference between the CO2 emissions (% of total fuel combustion) of Philippines and CO2 emissions (% of total fuel combustion) of Slovak Republic?
Offer a very short reply. -11.16. In the year 2008, what is the difference between the CO2 emissions (% of total fuel combustion) of Philippines and CO2 emissions (% of total fuel combustion) of Tanzania?
Your answer should be compact. -5.36. In the year 2008, what is the difference between the CO2 emissions (% of total fuel combustion) in Slovak Republic and CO2 emissions (% of total fuel combustion) in Tanzania?
Give a very brief answer. 5.8. In the year 2009, what is the difference between the CO2 emissions (% of total fuel combustion) of Kosovo and CO2 emissions (% of total fuel combustion) of Philippines?
Offer a terse response. -3.18. In the year 2009, what is the difference between the CO2 emissions (% of total fuel combustion) in Kosovo and CO2 emissions (% of total fuel combustion) in Slovak Republic?
Your answer should be compact. -15.41. In the year 2009, what is the difference between the CO2 emissions (% of total fuel combustion) of Kosovo and CO2 emissions (% of total fuel combustion) of Tanzania?
Your answer should be very brief. -5.75. In the year 2009, what is the difference between the CO2 emissions (% of total fuel combustion) in Philippines and CO2 emissions (% of total fuel combustion) in Slovak Republic?
Provide a short and direct response. -12.23. In the year 2009, what is the difference between the CO2 emissions (% of total fuel combustion) in Philippines and CO2 emissions (% of total fuel combustion) in Tanzania?
Your answer should be compact. -2.57. In the year 2009, what is the difference between the CO2 emissions (% of total fuel combustion) in Slovak Republic and CO2 emissions (% of total fuel combustion) in Tanzania?
Offer a very short reply. 9.66. What is the ratio of the CO2 emissions (% of total fuel combustion) in Kosovo in 2004 to that in 2005?
Offer a very short reply. 0.87. What is the ratio of the CO2 emissions (% of total fuel combustion) of Philippines in 2004 to that in 2005?
Offer a terse response. 1.2. What is the ratio of the CO2 emissions (% of total fuel combustion) of Slovak Republic in 2004 to that in 2005?
Your response must be concise. 0.94. What is the ratio of the CO2 emissions (% of total fuel combustion) in Tanzania in 2004 to that in 2005?
Your answer should be compact. 1.04. What is the ratio of the CO2 emissions (% of total fuel combustion) of Kosovo in 2004 to that in 2006?
Offer a very short reply. 0.84. What is the ratio of the CO2 emissions (% of total fuel combustion) in Philippines in 2004 to that in 2006?
Give a very brief answer. 1.14. What is the ratio of the CO2 emissions (% of total fuel combustion) in Slovak Republic in 2004 to that in 2006?
Offer a very short reply. 0.91. What is the ratio of the CO2 emissions (% of total fuel combustion) in Tanzania in 2004 to that in 2006?
Ensure brevity in your answer.  1.06. What is the ratio of the CO2 emissions (% of total fuel combustion) in Kosovo in 2004 to that in 2007?
Make the answer very short. 0.88. What is the ratio of the CO2 emissions (% of total fuel combustion) in Philippines in 2004 to that in 2007?
Provide a short and direct response. 1.32. What is the ratio of the CO2 emissions (% of total fuel combustion) of Slovak Republic in 2004 to that in 2007?
Ensure brevity in your answer.  0.96. What is the ratio of the CO2 emissions (% of total fuel combustion) in Tanzania in 2004 to that in 2007?
Your answer should be compact. 0.94. What is the ratio of the CO2 emissions (% of total fuel combustion) in Kosovo in 2004 to that in 2008?
Offer a very short reply. 0.66. What is the ratio of the CO2 emissions (% of total fuel combustion) in Philippines in 2004 to that in 2008?
Offer a very short reply. 1.3. What is the ratio of the CO2 emissions (% of total fuel combustion) of Slovak Republic in 2004 to that in 2008?
Offer a very short reply. 0.86. What is the ratio of the CO2 emissions (% of total fuel combustion) of Tanzania in 2004 to that in 2008?
Your response must be concise. 0.91. What is the ratio of the CO2 emissions (% of total fuel combustion) of Kosovo in 2004 to that in 2009?
Offer a very short reply. 0.69. What is the ratio of the CO2 emissions (% of total fuel combustion) of Philippines in 2004 to that in 2009?
Your answer should be very brief. 1.03. What is the ratio of the CO2 emissions (% of total fuel combustion) of Slovak Republic in 2004 to that in 2009?
Ensure brevity in your answer.  0.75. What is the ratio of the CO2 emissions (% of total fuel combustion) in Tanzania in 2004 to that in 2009?
Give a very brief answer. 1.04. What is the ratio of the CO2 emissions (% of total fuel combustion) in Kosovo in 2005 to that in 2006?
Your answer should be compact. 0.96. What is the ratio of the CO2 emissions (% of total fuel combustion) of Philippines in 2005 to that in 2006?
Your response must be concise. 0.95. What is the ratio of the CO2 emissions (% of total fuel combustion) in Slovak Republic in 2005 to that in 2006?
Your response must be concise. 0.97. What is the ratio of the CO2 emissions (% of total fuel combustion) of Tanzania in 2005 to that in 2006?
Provide a short and direct response. 1.02. What is the ratio of the CO2 emissions (% of total fuel combustion) of Kosovo in 2005 to that in 2007?
Provide a succinct answer. 1.01. What is the ratio of the CO2 emissions (% of total fuel combustion) of Philippines in 2005 to that in 2007?
Your answer should be compact. 1.1. What is the ratio of the CO2 emissions (% of total fuel combustion) in Slovak Republic in 2005 to that in 2007?
Your response must be concise. 1.02. What is the ratio of the CO2 emissions (% of total fuel combustion) of Tanzania in 2005 to that in 2007?
Your answer should be very brief. 0.91. What is the ratio of the CO2 emissions (% of total fuel combustion) in Kosovo in 2005 to that in 2008?
Your answer should be very brief. 0.76. What is the ratio of the CO2 emissions (% of total fuel combustion) of Philippines in 2005 to that in 2008?
Keep it short and to the point. 1.08. What is the ratio of the CO2 emissions (% of total fuel combustion) in Slovak Republic in 2005 to that in 2008?
Provide a succinct answer. 0.92. What is the ratio of the CO2 emissions (% of total fuel combustion) of Tanzania in 2005 to that in 2008?
Keep it short and to the point. 0.88. What is the ratio of the CO2 emissions (% of total fuel combustion) in Kosovo in 2005 to that in 2009?
Make the answer very short. 0.79. What is the ratio of the CO2 emissions (% of total fuel combustion) of Philippines in 2005 to that in 2009?
Keep it short and to the point. 0.86. What is the ratio of the CO2 emissions (% of total fuel combustion) in Slovak Republic in 2005 to that in 2009?
Ensure brevity in your answer.  0.8. What is the ratio of the CO2 emissions (% of total fuel combustion) in Kosovo in 2006 to that in 2007?
Your answer should be very brief. 1.05. What is the ratio of the CO2 emissions (% of total fuel combustion) of Philippines in 2006 to that in 2007?
Give a very brief answer. 1.16. What is the ratio of the CO2 emissions (% of total fuel combustion) of Slovak Republic in 2006 to that in 2007?
Ensure brevity in your answer.  1.06. What is the ratio of the CO2 emissions (% of total fuel combustion) in Tanzania in 2006 to that in 2007?
Keep it short and to the point. 0.89. What is the ratio of the CO2 emissions (% of total fuel combustion) in Kosovo in 2006 to that in 2008?
Keep it short and to the point. 0.79. What is the ratio of the CO2 emissions (% of total fuel combustion) in Philippines in 2006 to that in 2008?
Make the answer very short. 1.13. What is the ratio of the CO2 emissions (% of total fuel combustion) of Slovak Republic in 2006 to that in 2008?
Offer a very short reply. 0.95. What is the ratio of the CO2 emissions (% of total fuel combustion) of Tanzania in 2006 to that in 2008?
Offer a very short reply. 0.86. What is the ratio of the CO2 emissions (% of total fuel combustion) in Kosovo in 2006 to that in 2009?
Your answer should be compact. 0.82. What is the ratio of the CO2 emissions (% of total fuel combustion) of Philippines in 2006 to that in 2009?
Your answer should be compact. 0.91. What is the ratio of the CO2 emissions (% of total fuel combustion) in Slovak Republic in 2006 to that in 2009?
Keep it short and to the point. 0.83. What is the ratio of the CO2 emissions (% of total fuel combustion) in Tanzania in 2006 to that in 2009?
Ensure brevity in your answer.  0.99. What is the ratio of the CO2 emissions (% of total fuel combustion) of Kosovo in 2007 to that in 2008?
Your answer should be compact. 0.75. What is the ratio of the CO2 emissions (% of total fuel combustion) in Philippines in 2007 to that in 2008?
Your answer should be compact. 0.98. What is the ratio of the CO2 emissions (% of total fuel combustion) of Slovak Republic in 2007 to that in 2008?
Make the answer very short. 0.9. What is the ratio of the CO2 emissions (% of total fuel combustion) of Kosovo in 2007 to that in 2009?
Your answer should be compact. 0.78. What is the ratio of the CO2 emissions (% of total fuel combustion) of Philippines in 2007 to that in 2009?
Your response must be concise. 0.78. What is the ratio of the CO2 emissions (% of total fuel combustion) of Slovak Republic in 2007 to that in 2009?
Your response must be concise. 0.79. What is the ratio of the CO2 emissions (% of total fuel combustion) in Tanzania in 2007 to that in 2009?
Ensure brevity in your answer.  1.11. What is the ratio of the CO2 emissions (% of total fuel combustion) of Kosovo in 2008 to that in 2009?
Provide a succinct answer. 1.04. What is the ratio of the CO2 emissions (% of total fuel combustion) in Philippines in 2008 to that in 2009?
Offer a very short reply. 0.8. What is the ratio of the CO2 emissions (% of total fuel combustion) of Slovak Republic in 2008 to that in 2009?
Your answer should be compact. 0.87. What is the difference between the highest and the second highest CO2 emissions (% of total fuel combustion) in Kosovo?
Provide a short and direct response. 0.15. What is the difference between the highest and the second highest CO2 emissions (% of total fuel combustion) in Philippines?
Provide a succinct answer. 0.24. What is the difference between the highest and the second highest CO2 emissions (% of total fuel combustion) in Slovak Republic?
Your response must be concise. 2.49. What is the difference between the highest and the second highest CO2 emissions (% of total fuel combustion) in Tanzania?
Keep it short and to the point. 0.36. What is the difference between the highest and the lowest CO2 emissions (% of total fuel combustion) of Kosovo?
Your answer should be compact. 1.35. What is the difference between the highest and the lowest CO2 emissions (% of total fuel combustion) in Philippines?
Provide a short and direct response. 1.79. What is the difference between the highest and the lowest CO2 emissions (% of total fuel combustion) of Slovak Republic?
Provide a succinct answer. 4.76. What is the difference between the highest and the lowest CO2 emissions (% of total fuel combustion) of Tanzania?
Make the answer very short. 1.5. 